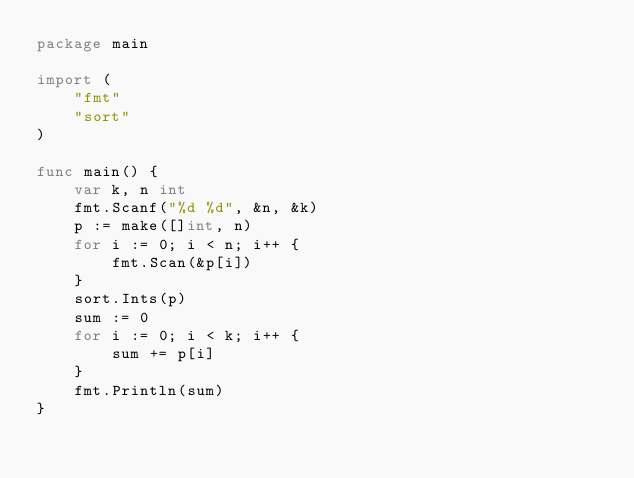Convert code to text. <code><loc_0><loc_0><loc_500><loc_500><_Go_>package main

import (
	"fmt"
	"sort"
)

func main() {
	var k, n int
	fmt.Scanf("%d %d", &n, &k)
	p := make([]int, n)
	for i := 0; i < n; i++ {
		fmt.Scan(&p[i])
	}
	sort.Ints(p)
	sum := 0
	for i := 0; i < k; i++ {
		sum += p[i]
	}
	fmt.Println(sum)
}</code> 